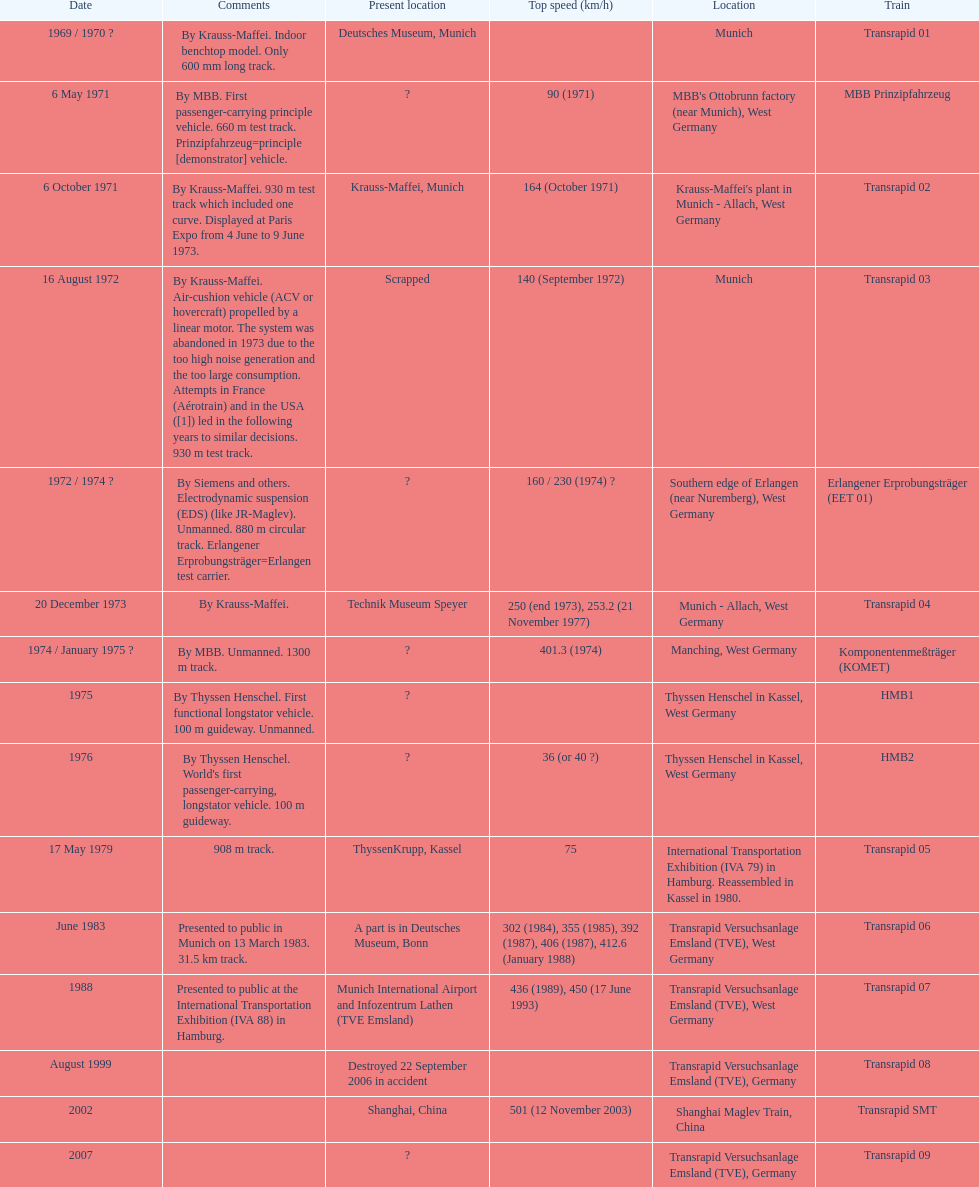What is the number of trains that were either scrapped or destroyed? 2. 